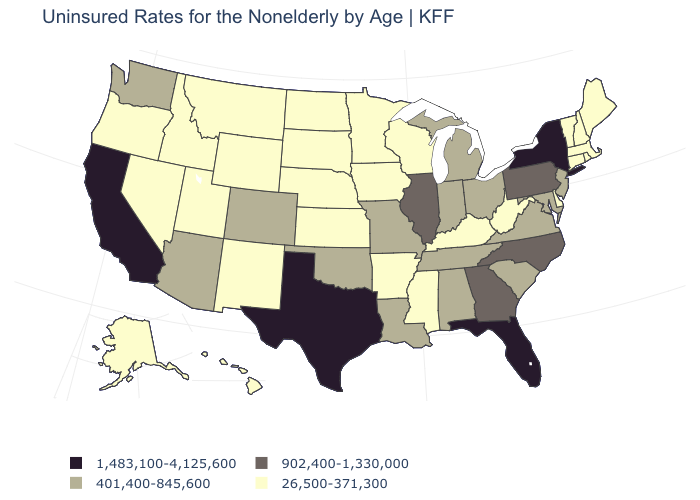Among the states that border New Jersey , which have the lowest value?
Answer briefly. Delaware. Does the map have missing data?
Quick response, please. No. Which states have the lowest value in the USA?
Keep it brief. Alaska, Arkansas, Connecticut, Delaware, Hawaii, Idaho, Iowa, Kansas, Kentucky, Maine, Massachusetts, Minnesota, Mississippi, Montana, Nebraska, Nevada, New Hampshire, New Mexico, North Dakota, Oregon, Rhode Island, South Dakota, Utah, Vermont, West Virginia, Wisconsin, Wyoming. Does the map have missing data?
Give a very brief answer. No. Which states hav the highest value in the West?
Write a very short answer. California. Does the first symbol in the legend represent the smallest category?
Concise answer only. No. What is the value of New Hampshire?
Concise answer only. 26,500-371,300. Name the states that have a value in the range 902,400-1,330,000?
Give a very brief answer. Georgia, Illinois, North Carolina, Pennsylvania. What is the highest value in the USA?
Short answer required. 1,483,100-4,125,600. Does Kentucky have a lower value than Virginia?
Give a very brief answer. Yes. What is the value of New Mexico?
Short answer required. 26,500-371,300. Does Iowa have the same value as Nebraska?
Quick response, please. Yes. Is the legend a continuous bar?
Concise answer only. No. Among the states that border New York , does Connecticut have the lowest value?
Keep it brief. Yes. 